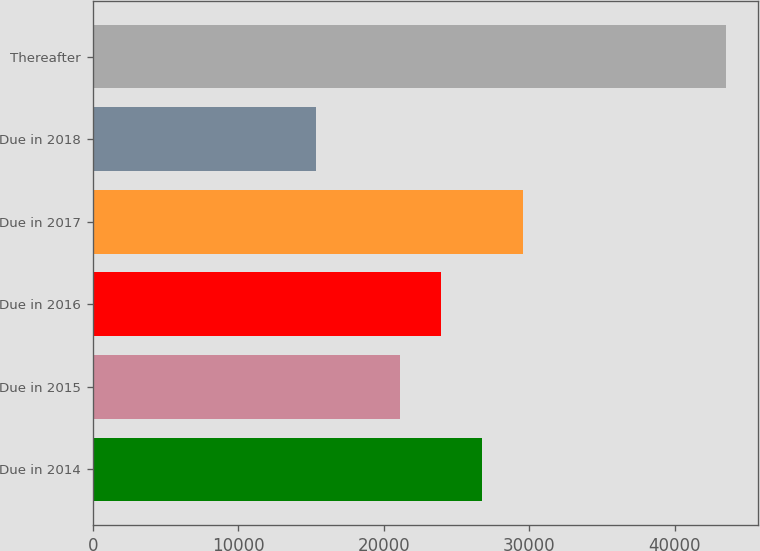Convert chart to OTSL. <chart><loc_0><loc_0><loc_500><loc_500><bar_chart><fcel>Due in 2014<fcel>Due in 2015<fcel>Due in 2016<fcel>Due in 2017<fcel>Due in 2018<fcel>Thereafter<nl><fcel>26737.4<fcel>21090<fcel>23913.7<fcel>29561.1<fcel>15308<fcel>43545<nl></chart> 